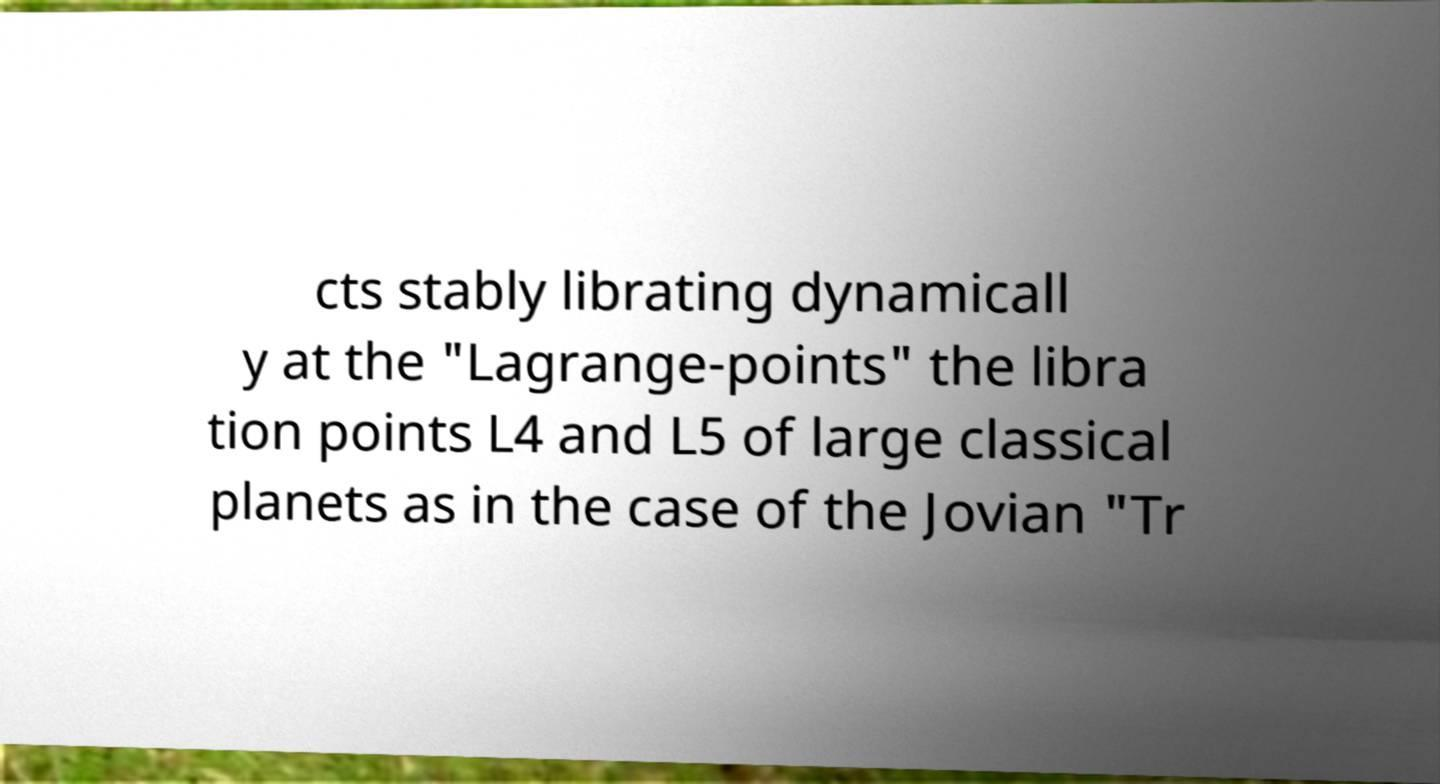Please identify and transcribe the text found in this image. cts stably librating dynamicall y at the "Lagrange-points" the libra tion points L4 and L5 of large classical planets as in the case of the Jovian "Tr 